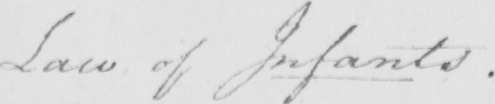Can you tell me what this handwritten text says? Law of Infants . 